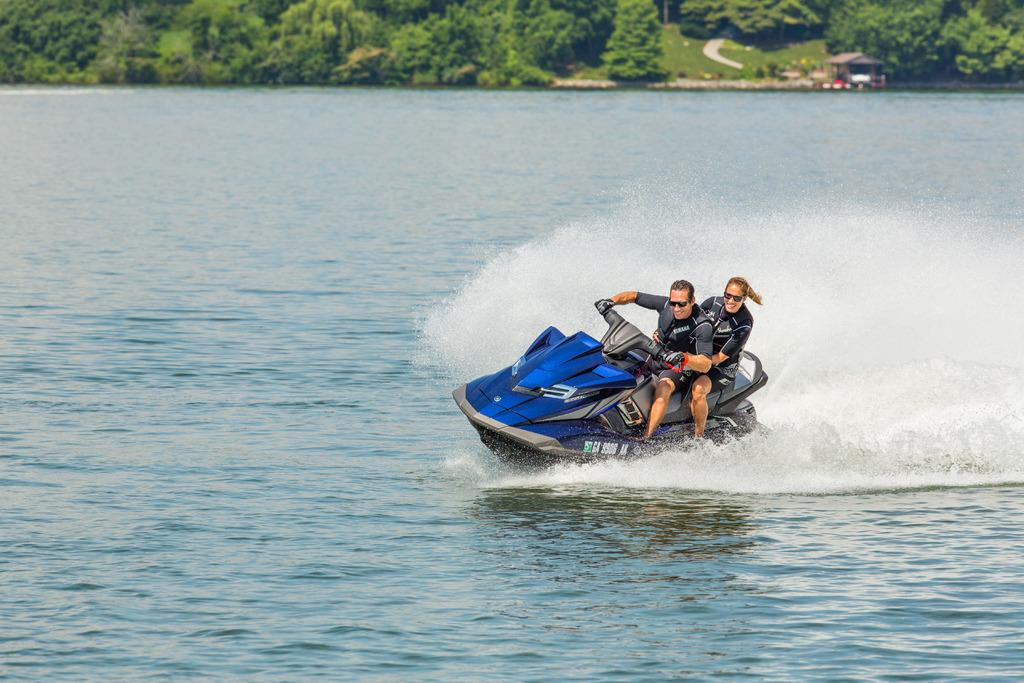How many people are in the image? There are two persons in the image. What are the persons doing in the image? The persons are sitting on a jet ski. Where is the jet ski located in the image? The jet ski is floating on the water. What can be seen in the background of the image? There are trees and a wooden house in the background of the image. What type of club is the persons holding in the image? There is no club present in the image; the persons are sitting on a jet ski. How much debt do the persons owe in the image? There is no mention of debt in the image; it features two persons on a jet ski in a natural setting. 